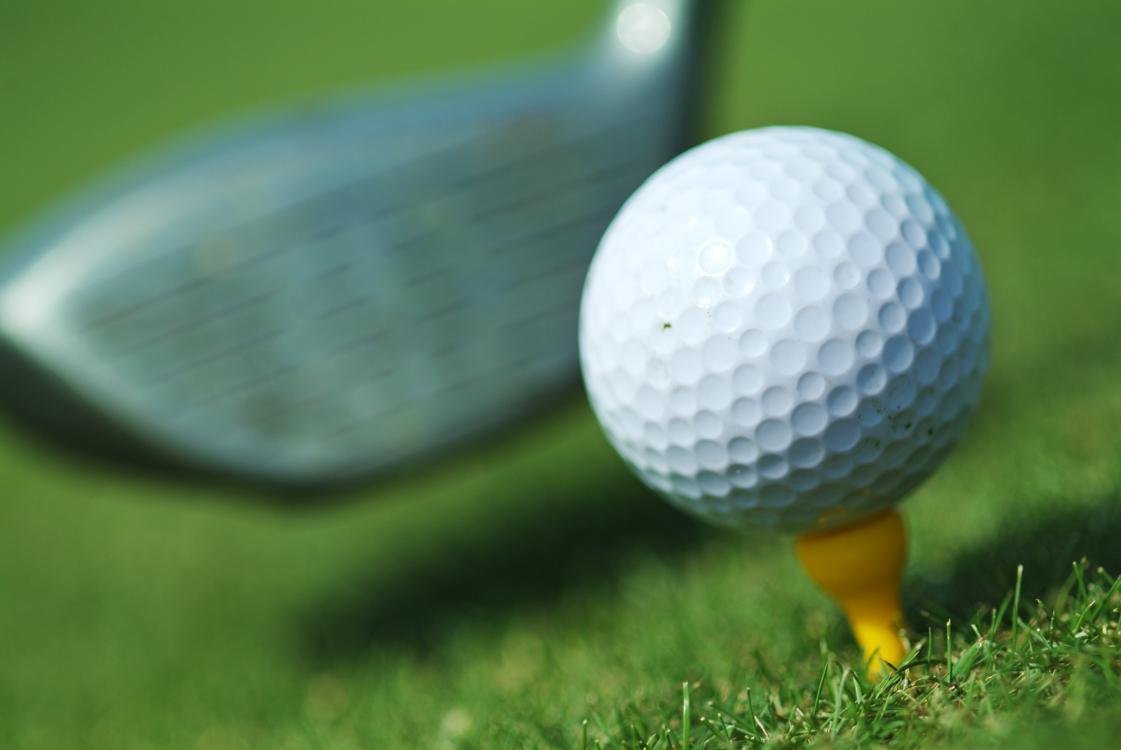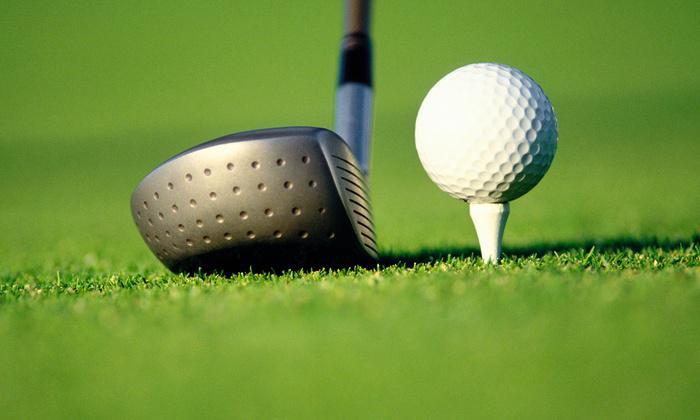The first image is the image on the left, the second image is the image on the right. Analyze the images presented: Is the assertion "At least one image includes a ball on a golf tee." valid? Answer yes or no. Yes. The first image is the image on the left, the second image is the image on the right. For the images displayed, is the sentence "There are two balls near the hole in one of the images." factually correct? Answer yes or no. No. 